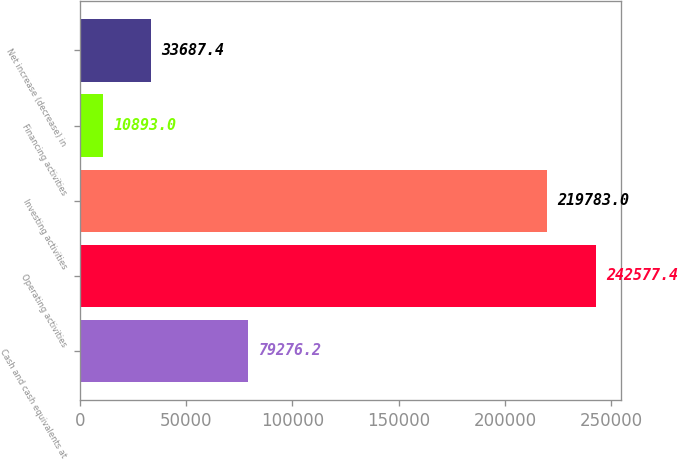Convert chart to OTSL. <chart><loc_0><loc_0><loc_500><loc_500><bar_chart><fcel>Cash and cash equivalents at<fcel>Operating activities<fcel>Investing activities<fcel>Financing activities<fcel>Net increase (decrease) in<nl><fcel>79276.2<fcel>242577<fcel>219783<fcel>10893<fcel>33687.4<nl></chart> 